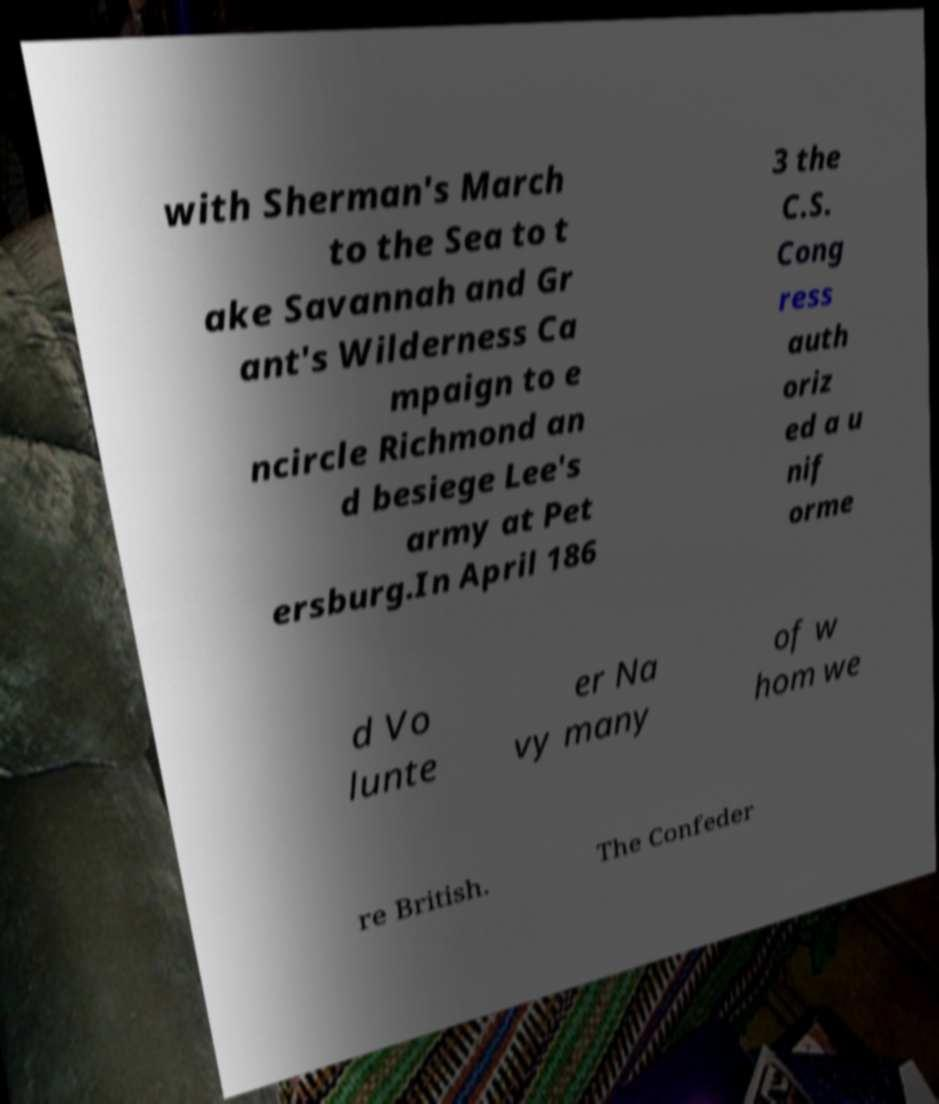For documentation purposes, I need the text within this image transcribed. Could you provide that? with Sherman's March to the Sea to t ake Savannah and Gr ant's Wilderness Ca mpaign to e ncircle Richmond an d besiege Lee's army at Pet ersburg.In April 186 3 the C.S. Cong ress auth oriz ed a u nif orme d Vo lunte er Na vy many of w hom we re British. The Confeder 